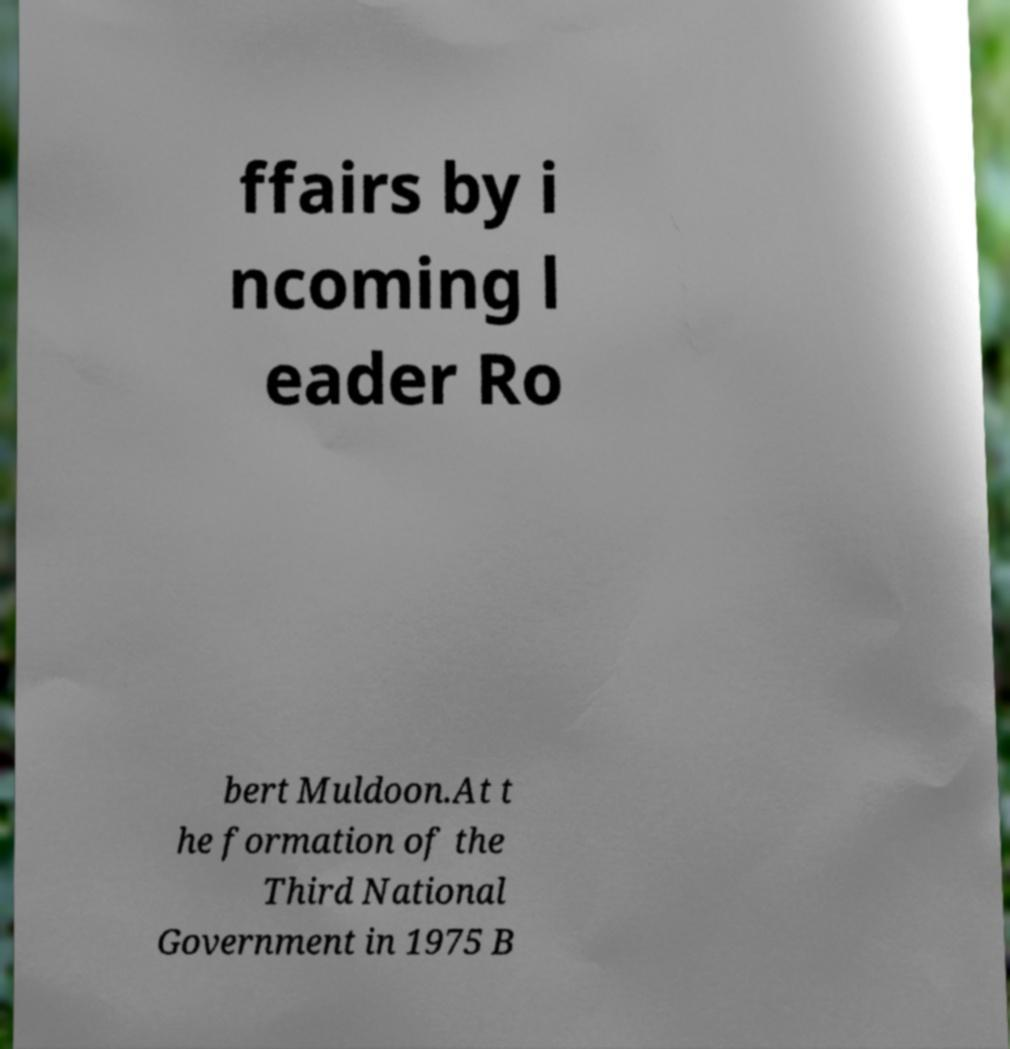What messages or text are displayed in this image? I need them in a readable, typed format. ffairs by i ncoming l eader Ro bert Muldoon.At t he formation of the Third National Government in 1975 B 